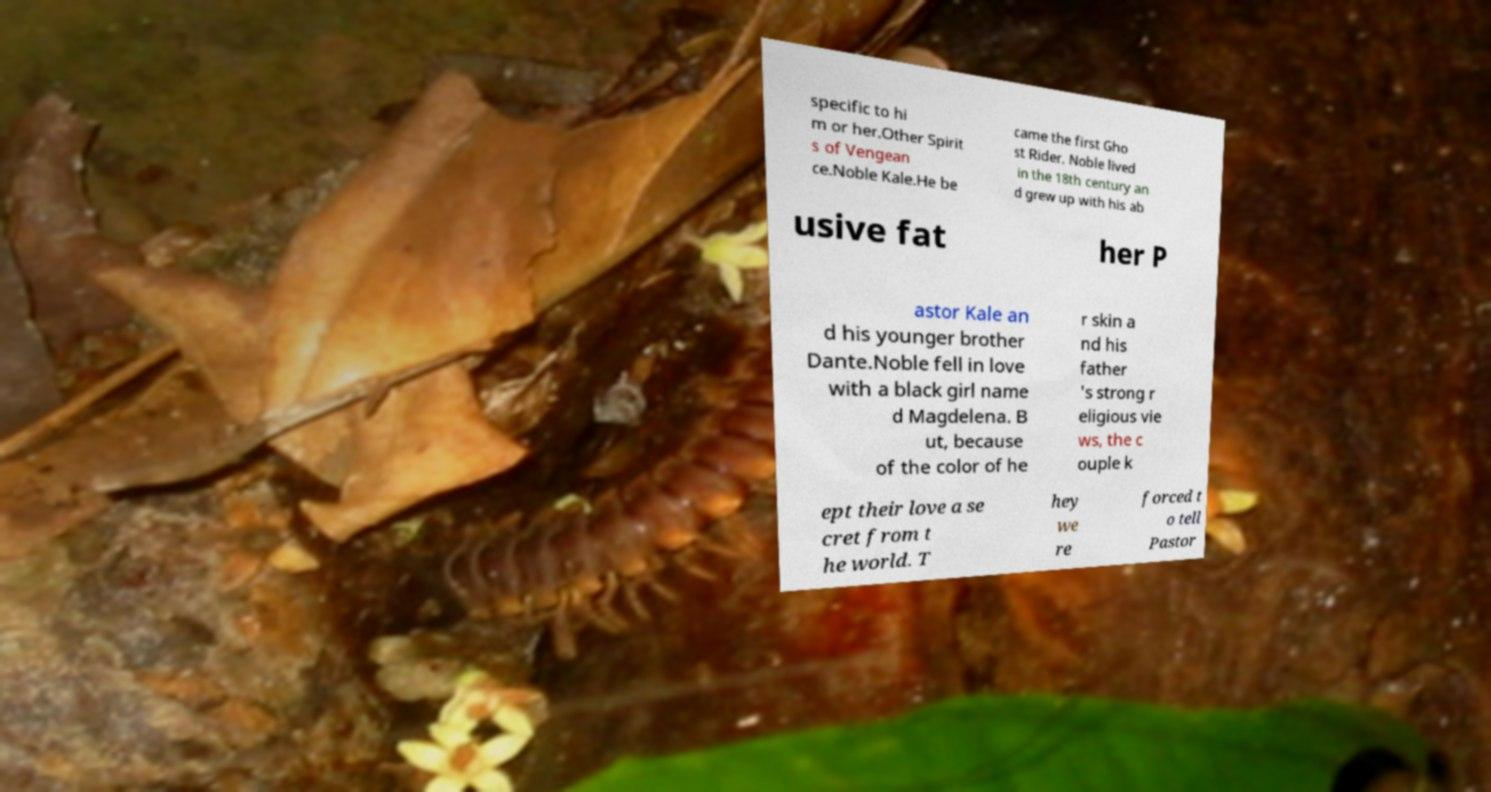Can you read and provide the text displayed in the image?This photo seems to have some interesting text. Can you extract and type it out for me? specific to hi m or her.Other Spirit s of Vengean ce.Noble Kale.He be came the first Gho st Rider. Noble lived in the 18th century an d grew up with his ab usive fat her P astor Kale an d his younger brother Dante.Noble fell in love with a black girl name d Magdelena. B ut, because of the color of he r skin a nd his father 's strong r eligious vie ws, the c ouple k ept their love a se cret from t he world. T hey we re forced t o tell Pastor 